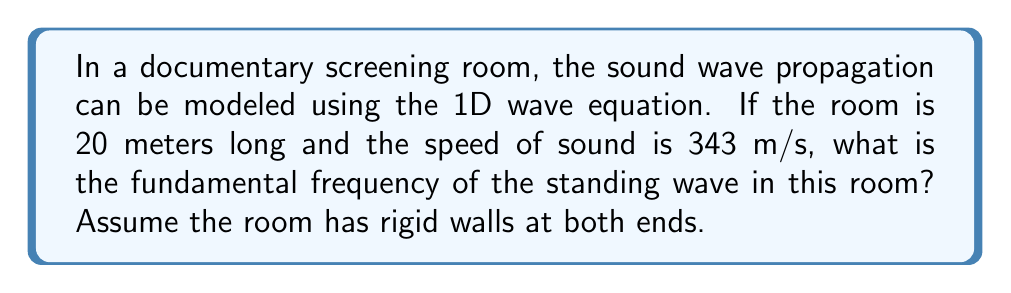Show me your answer to this math problem. To solve this problem, we'll follow these steps:

1) The 1D wave equation for sound waves is:

   $$\frac{\partial^2 u}{\partial t^2} = c^2 \frac{\partial^2 u}{\partial x^2}$$

   where $u$ is the displacement, $t$ is time, $x$ is position, and $c$ is the speed of sound.

2) For a room with rigid walls, we have fixed boundary conditions at $x=0$ and $x=L$, where $L$ is the length of the room. This leads to standing waves.

3) The general solution for standing waves is:

   $$u(x,t) = A \sin(kx) \cos(\omega t)$$

   where $k$ is the wave number and $\omega$ is the angular frequency.

4) The boundary conditions require that $\sin(kL) = 0$, which means:

   $$kL = n\pi$$

   where $n$ is a positive integer.

5) The fundamental frequency corresponds to $n=1$, so:

   $$k_1 = \frac{\pi}{L}$$

6) We know that $\omega = ck$ for any wave, so the fundamental angular frequency is:

   $$\omega_1 = ck_1 = c\frac{\pi}{L}$$

7) The frequency $f$ is related to $\omega$ by $\omega = 2\pi f$, so:

   $$f_1 = \frac{c}{2L}$$

8) Plugging in the values:

   $$f_1 = \frac{343 \text{ m/s}}{2(20 \text{ m})} = 8.575 \text{ Hz}$$

9) Rounding to two decimal places:

   $$f_1 \approx 8.58 \text{ Hz}$$
Answer: 8.58 Hz 